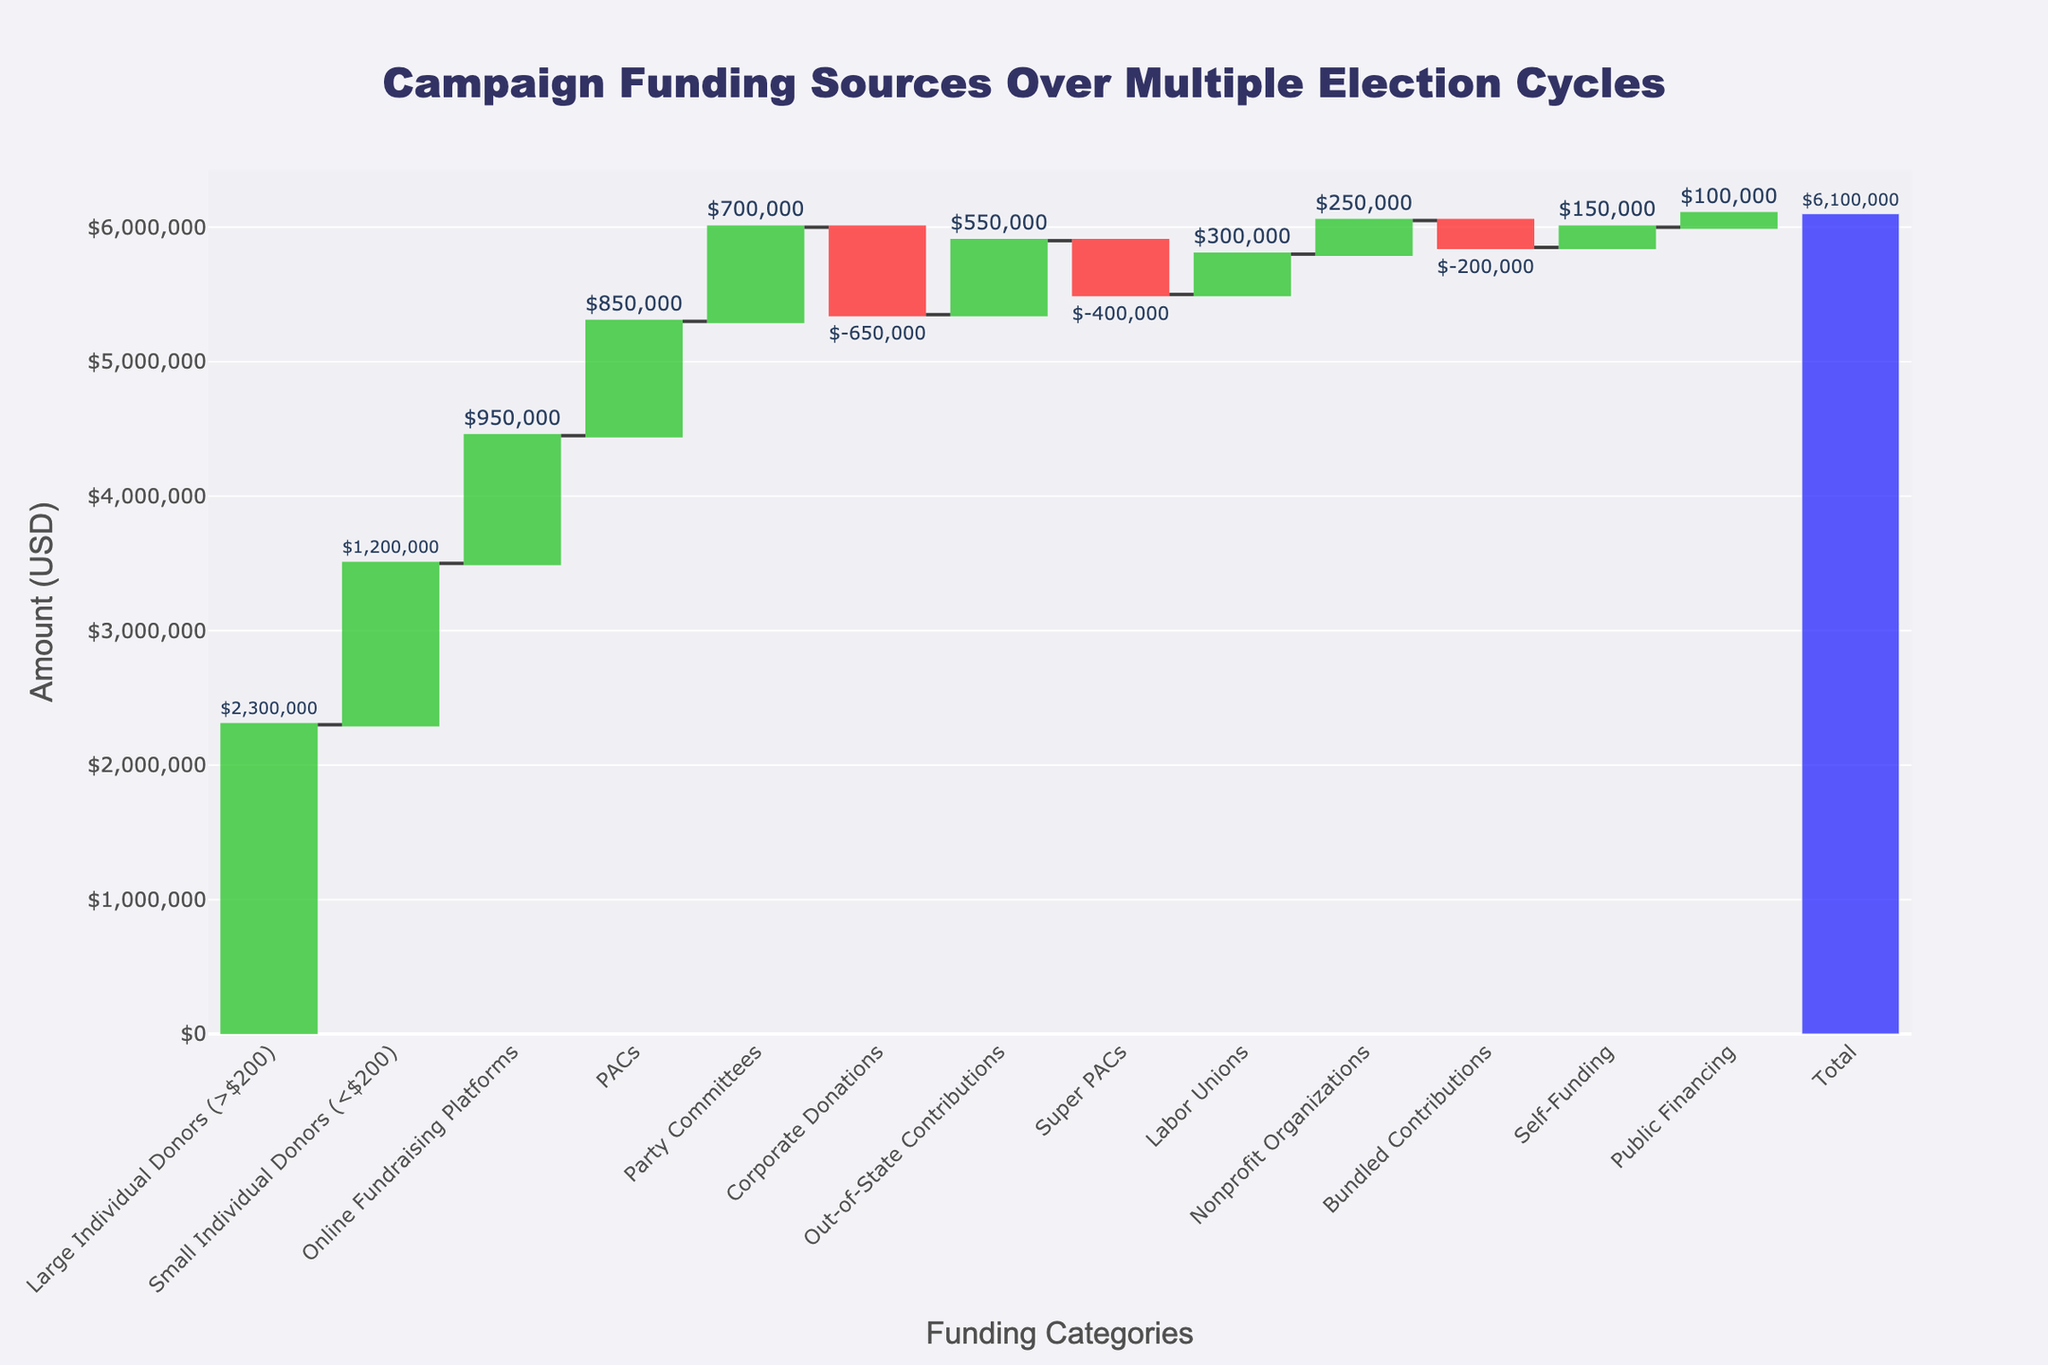What is the total amount of campaign funding from all sources? To find the total amount, we sum the values from all individual funding categories.
Answer: $5,500,000 What category contributes the most to the campaign funding? Looking at the chart, the category with the largest positive column will be the one contributing the most. Large Individual Donors have the highest contribution at $2,300,000.
Answer: Large Individual Donors Which categories have negative values? Categories with negative values will be those with decreasing markers. Super PACs, Corporate Donations, and Bundled Contributions have negative values.
Answer: Super PACs, Corporate Donations, Bundled Contributions How much more did Small Individual Donors contribute compared to Self-Funding? To find the difference, subtract the value of Self-Funding from Small Individual Donors: $1,200,000 - $150,000.
Answer: $1,050,000 What is the combined contribution from PACs and Party Committees? Add the values for PACs and Party Committees: $850,000 + $700,000.
Answer: $1,550,000 Which has a higher contribution, Online Fundraising Platforms or Out-of-State Contributions? Comparing the two columns, Online Fundraising Platforms is higher at $950,000 compared to Out-of-State Contributions at $550,000.
Answer: Online Fundraising Platforms What is the difference between contributions from Labor Unions and Nonprofit Organizations? Subtract the value of Nonprofit Organizations from Labor Unions: $300,000 - $250,000.
Answer: $50,000 Which funding category has the smallest positive contribution? Among the positive values, Public Financing is the smallest with $100,000.
Answer: Public Financing How do online fundraising contributions compare to traditional PAC contributions? Online Fundraising Platforms contribute $950,000, which is higher than PACs at $850,000.
Answer: Online Fundraising Platforms contribute more What is the net effect of Super PACs and Corporate Donations on total campaign funding? Summing up the negative values of Super PACs and Corporate Donations: -$400,000 + -$650,000.
Answer: -$1,050,000 